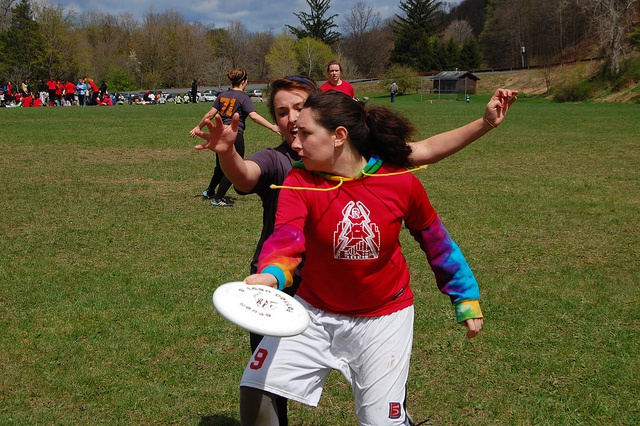Describe the objects in this image and their specific colors. I can see people in gray, maroon, lightgray, black, and brown tones, people in gray, black, maroon, olive, and brown tones, frisbee in gray, white, and darkgray tones, people in gray, black, olive, and maroon tones, and people in gray, black, darkgreen, and maroon tones in this image. 